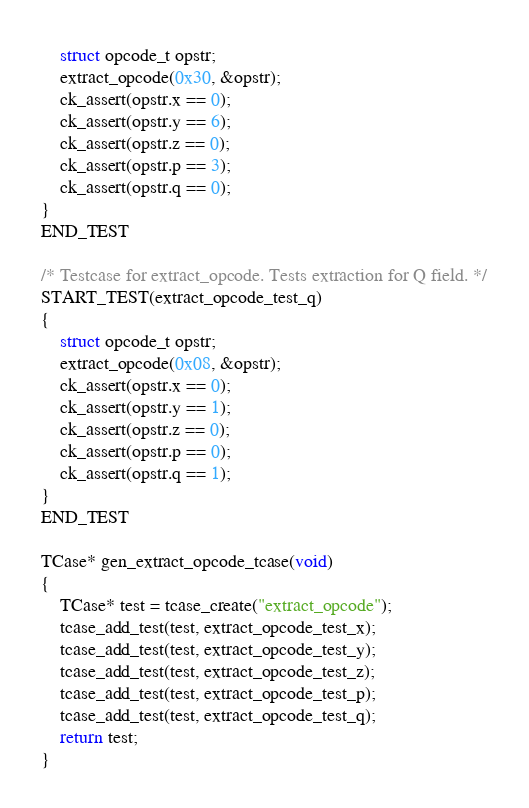<code> <loc_0><loc_0><loc_500><loc_500><_C_>    struct opcode_t opstr;
    extract_opcode(0x30, &opstr);
    ck_assert(opstr.x == 0);
    ck_assert(opstr.y == 6);
    ck_assert(opstr.z == 0);
    ck_assert(opstr.p == 3);
    ck_assert(opstr.q == 0);
}
END_TEST

/* Testcase for extract_opcode. Tests extraction for Q field. */
START_TEST(extract_opcode_test_q)
{
    struct opcode_t opstr;
    extract_opcode(0x08, &opstr);
    ck_assert(opstr.x == 0);
    ck_assert(opstr.y == 1);
    ck_assert(opstr.z == 0);
    ck_assert(opstr.p == 0);
    ck_assert(opstr.q == 1);
}
END_TEST

TCase* gen_extract_opcode_tcase(void)
{
    TCase* test = tcase_create("extract_opcode");
    tcase_add_test(test, extract_opcode_test_x);
    tcase_add_test(test, extract_opcode_test_y);
    tcase_add_test(test, extract_opcode_test_z);
    tcase_add_test(test, extract_opcode_test_p);
    tcase_add_test(test, extract_opcode_test_q);
    return test;
}
</code> 